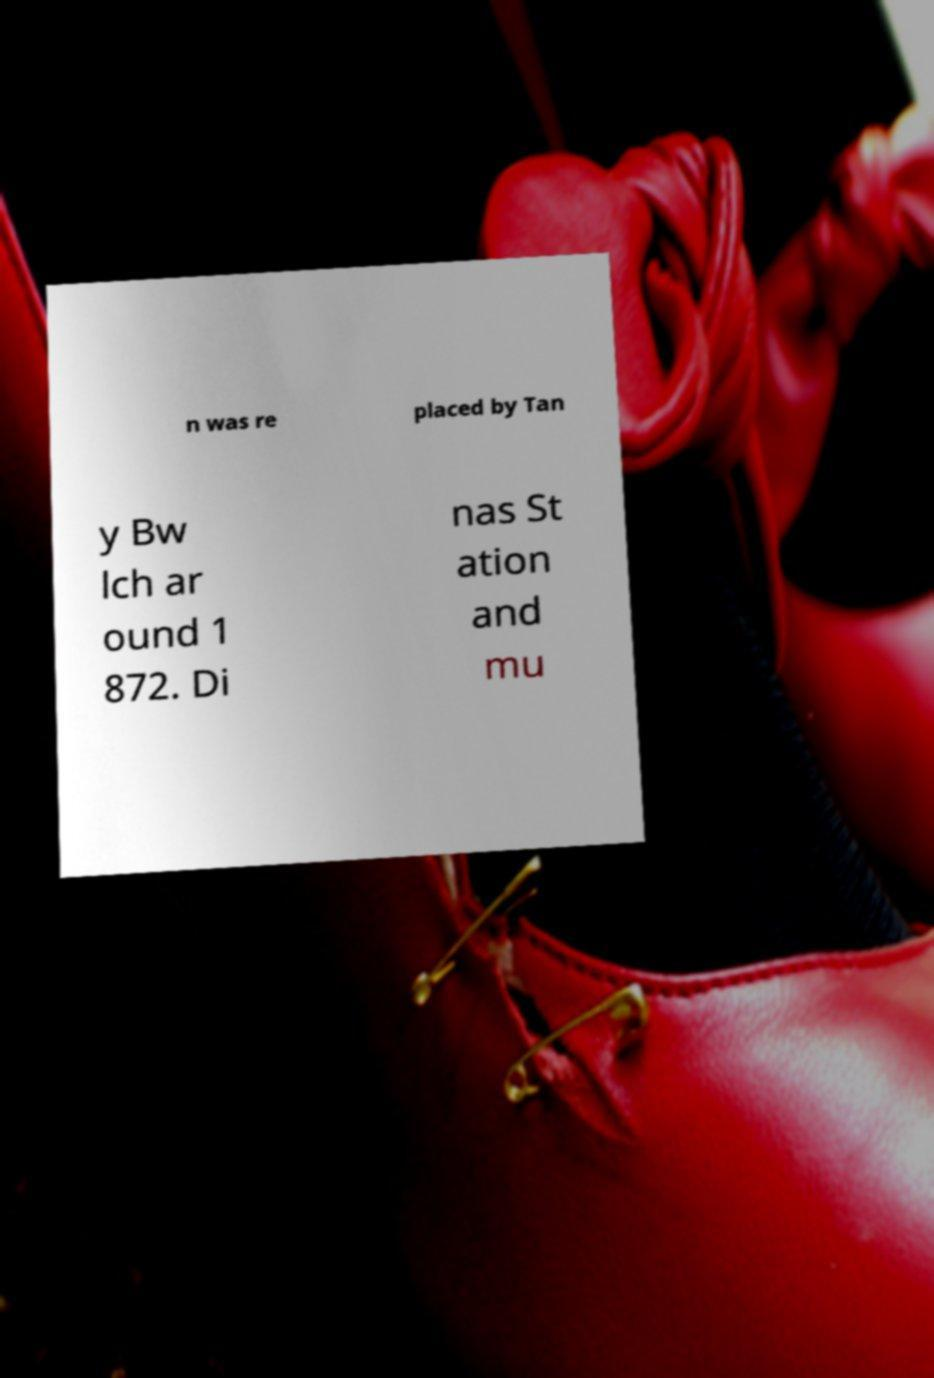Please identify and transcribe the text found in this image. n was re placed by Tan y Bw lch ar ound 1 872. Di nas St ation and mu 